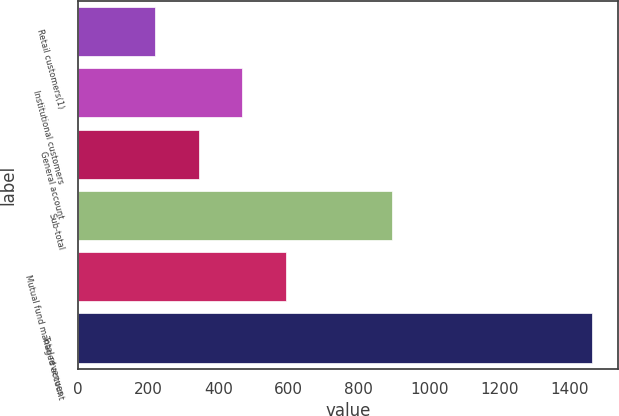Convert chart. <chart><loc_0><loc_0><loc_500><loc_500><bar_chart><fcel>Retail customers(1)<fcel>Institutional customers<fcel>General account<fcel>Sub-total<fcel>Mutual fund managed account<fcel>Total revenues<nl><fcel>219<fcel>468<fcel>343.5<fcel>895<fcel>592.5<fcel>1464<nl></chart> 